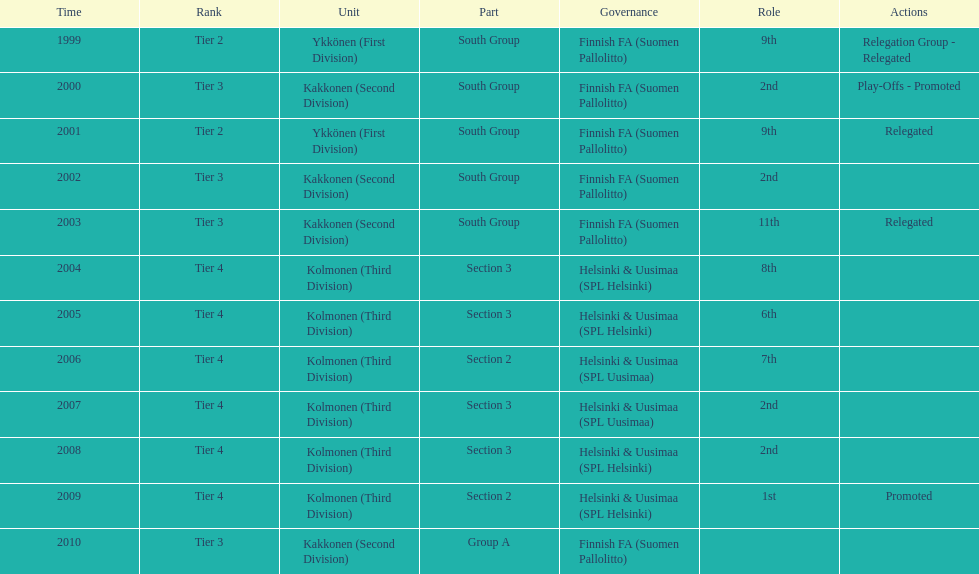What division were they in the most, section 3 or 2? 3. 